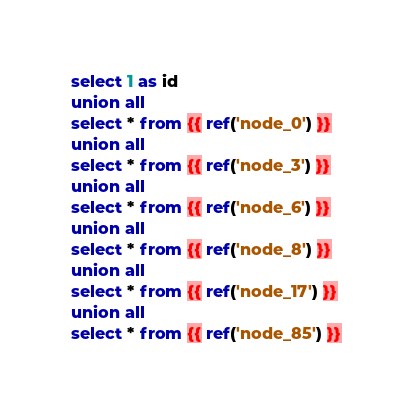Convert code to text. <code><loc_0><loc_0><loc_500><loc_500><_SQL_>select 1 as id
union all
select * from {{ ref('node_0') }}
union all
select * from {{ ref('node_3') }}
union all
select * from {{ ref('node_6') }}
union all
select * from {{ ref('node_8') }}
union all
select * from {{ ref('node_17') }}
union all
select * from {{ ref('node_85') }}
</code> 